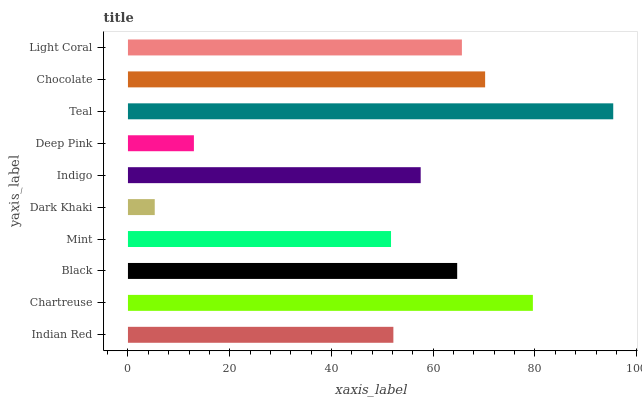Is Dark Khaki the minimum?
Answer yes or no. Yes. Is Teal the maximum?
Answer yes or no. Yes. Is Chartreuse the minimum?
Answer yes or no. No. Is Chartreuse the maximum?
Answer yes or no. No. Is Chartreuse greater than Indian Red?
Answer yes or no. Yes. Is Indian Red less than Chartreuse?
Answer yes or no. Yes. Is Indian Red greater than Chartreuse?
Answer yes or no. No. Is Chartreuse less than Indian Red?
Answer yes or no. No. Is Black the high median?
Answer yes or no. Yes. Is Indigo the low median?
Answer yes or no. Yes. Is Light Coral the high median?
Answer yes or no. No. Is Black the low median?
Answer yes or no. No. 